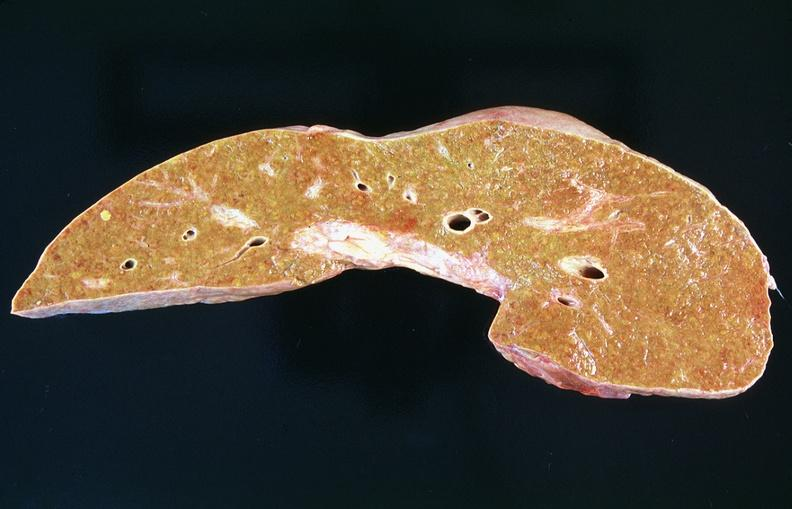what does this image show?
Answer the question using a single word or phrase. Liver 